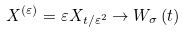Convert formula to latex. <formula><loc_0><loc_0><loc_500><loc_500>X ^ { \left ( \varepsilon \right ) } = \varepsilon X _ { t / \varepsilon ^ { 2 } } \rightarrow W _ { \sigma } \left ( t \right )</formula> 